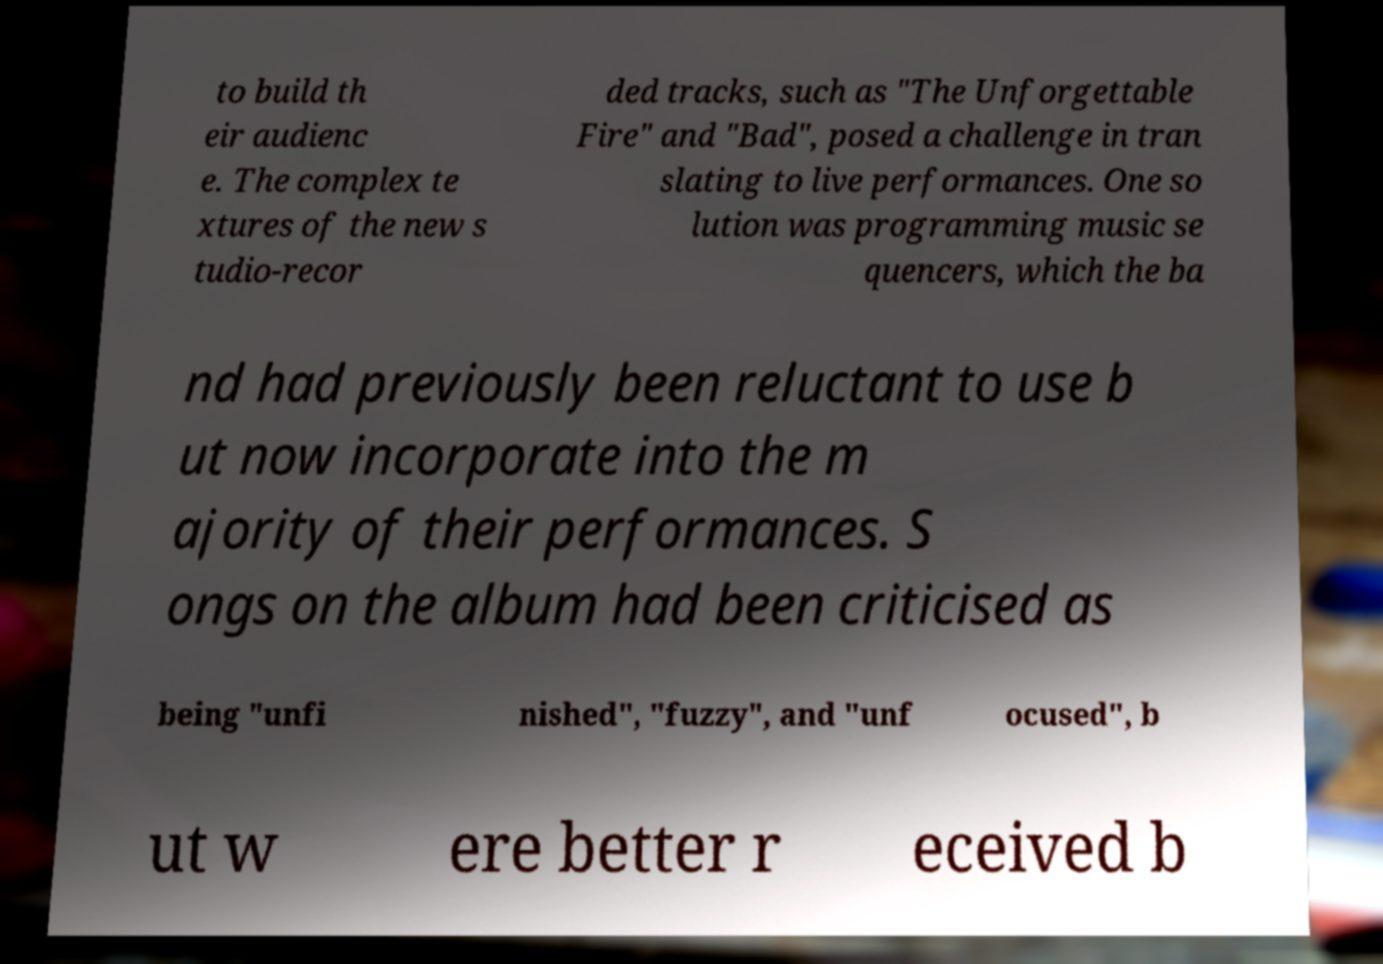Could you assist in decoding the text presented in this image and type it out clearly? to build th eir audienc e. The complex te xtures of the new s tudio-recor ded tracks, such as "The Unforgettable Fire" and "Bad", posed a challenge in tran slating to live performances. One so lution was programming music se quencers, which the ba nd had previously been reluctant to use b ut now incorporate into the m ajority of their performances. S ongs on the album had been criticised as being "unfi nished", "fuzzy", and "unf ocused", b ut w ere better r eceived b 